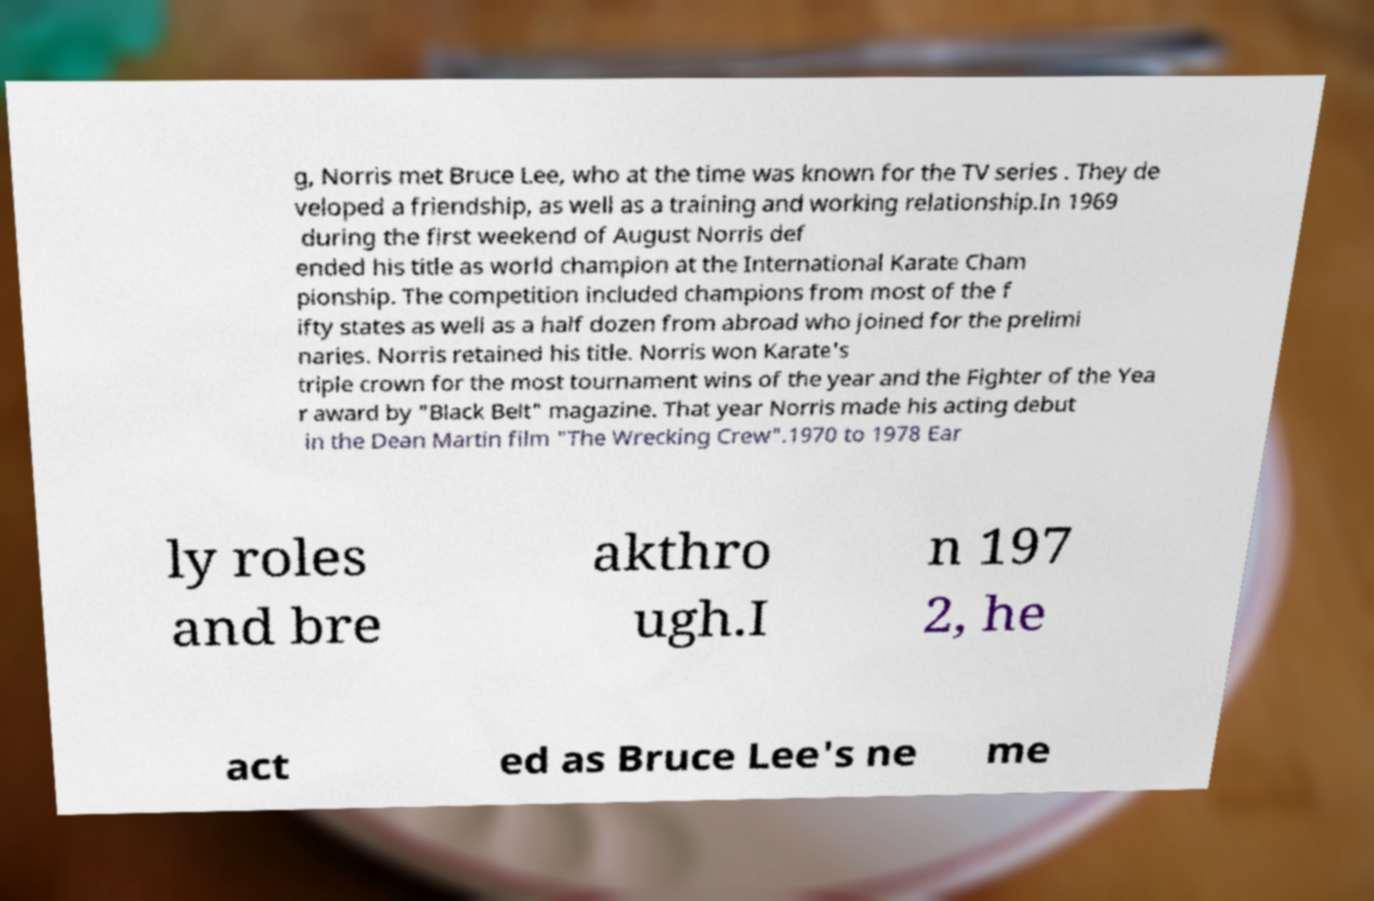Could you assist in decoding the text presented in this image and type it out clearly? g, Norris met Bruce Lee, who at the time was known for the TV series . They de veloped a friendship, as well as a training and working relationship.In 1969 during the first weekend of August Norris def ended his title as world champion at the International Karate Cham pionship. The competition included champions from most of the f ifty states as well as a half dozen from abroad who joined for the prelimi naries. Norris retained his title. Norris won Karate's triple crown for the most tournament wins of the year and the Fighter of the Yea r award by "Black Belt" magazine. That year Norris made his acting debut in the Dean Martin film "The Wrecking Crew".1970 to 1978 Ear ly roles and bre akthro ugh.I n 197 2, he act ed as Bruce Lee's ne me 